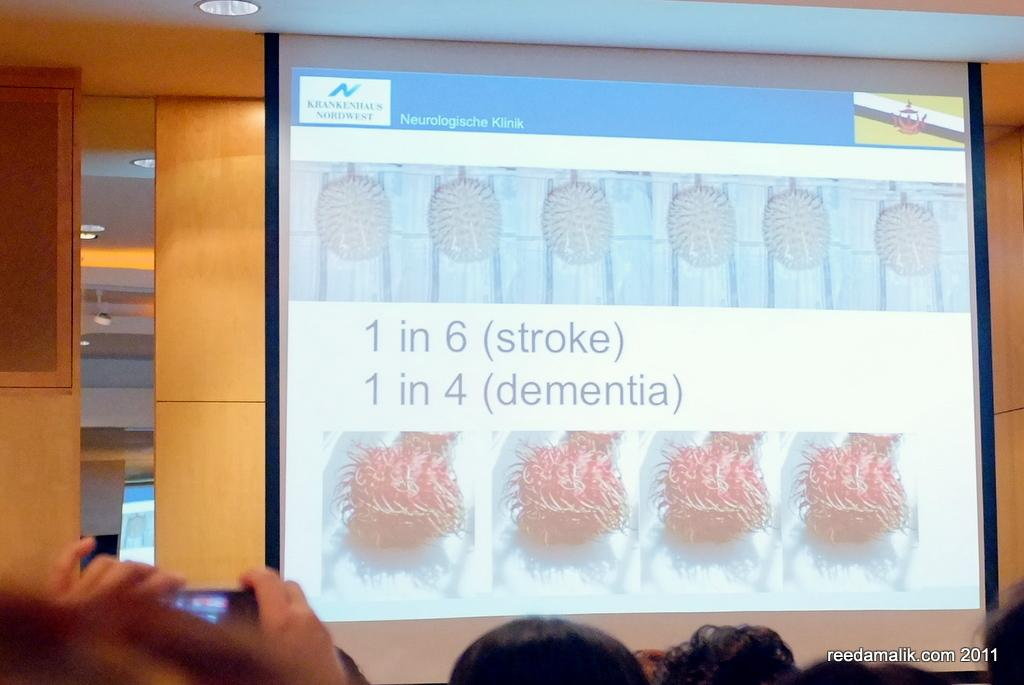What is located on the right side of the image? There is a projected screen on the right side of the image. What might be displayed on the projected screen? The content displayed on the projected screen cannot be determined from the image alone. Can you describe the size or shape of the projected screen? The size or shape of the projected screen cannot be determined from the image alone. What type of advertisement is being displayed on the floor in the image? There is no advertisement displayed on the floor in the image; the only visible element is the projected screen on the right side. 